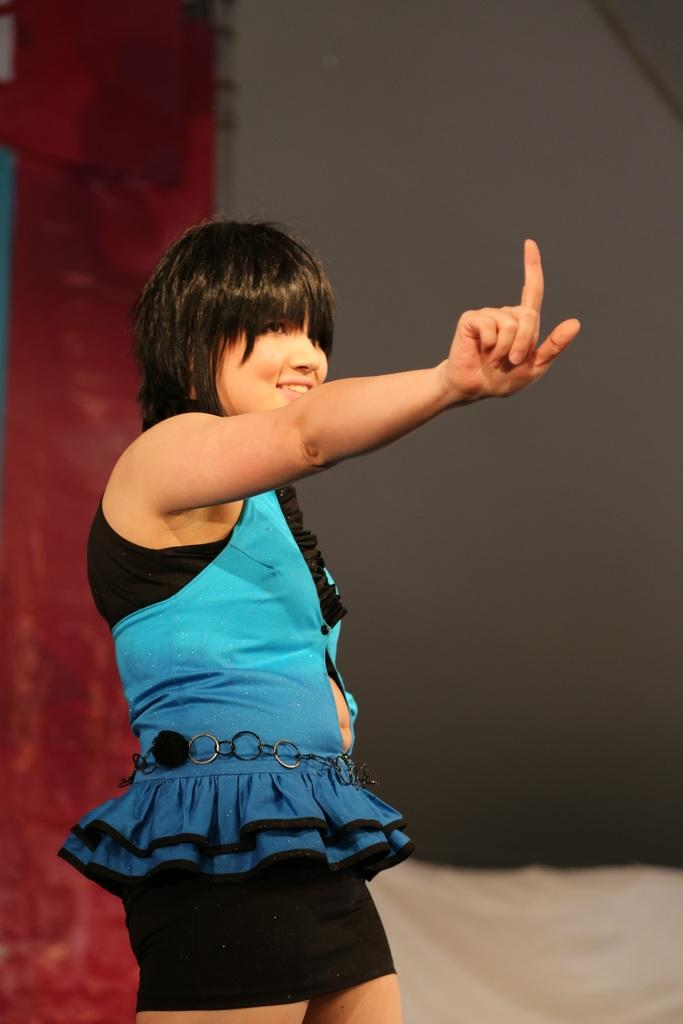What is the main subject of the image? The main subject of the image is a girl standing. What can be seen in the background of the image? There is a wall in the background of the image. What type of machine is the girl controlling in the image? There is no machine present in the image, and the girl is not controlling anything. 